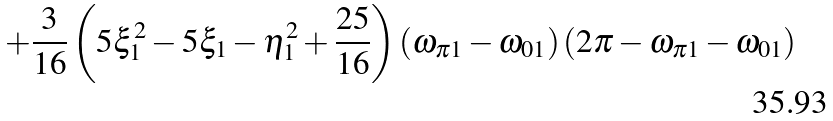Convert formula to latex. <formula><loc_0><loc_0><loc_500><loc_500>+ \frac { 3 } { 1 6 } \left ( 5 \xi _ { 1 } ^ { 2 } - 5 \xi _ { 1 } - \eta _ { 1 } ^ { 2 } + \frac { 2 5 } { 1 6 } \right ) \left ( \omega _ { \pi 1 } - \omega _ { 0 1 } \right ) \left ( 2 \pi - \omega _ { \pi 1 } - \omega _ { 0 1 } \right )</formula> 